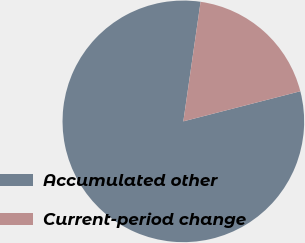Convert chart to OTSL. <chart><loc_0><loc_0><loc_500><loc_500><pie_chart><fcel>Accumulated other<fcel>Current-period change<nl><fcel>81.29%<fcel>18.71%<nl></chart> 